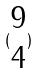<formula> <loc_0><loc_0><loc_500><loc_500>( \begin{matrix} 9 \\ 4 \end{matrix} )</formula> 